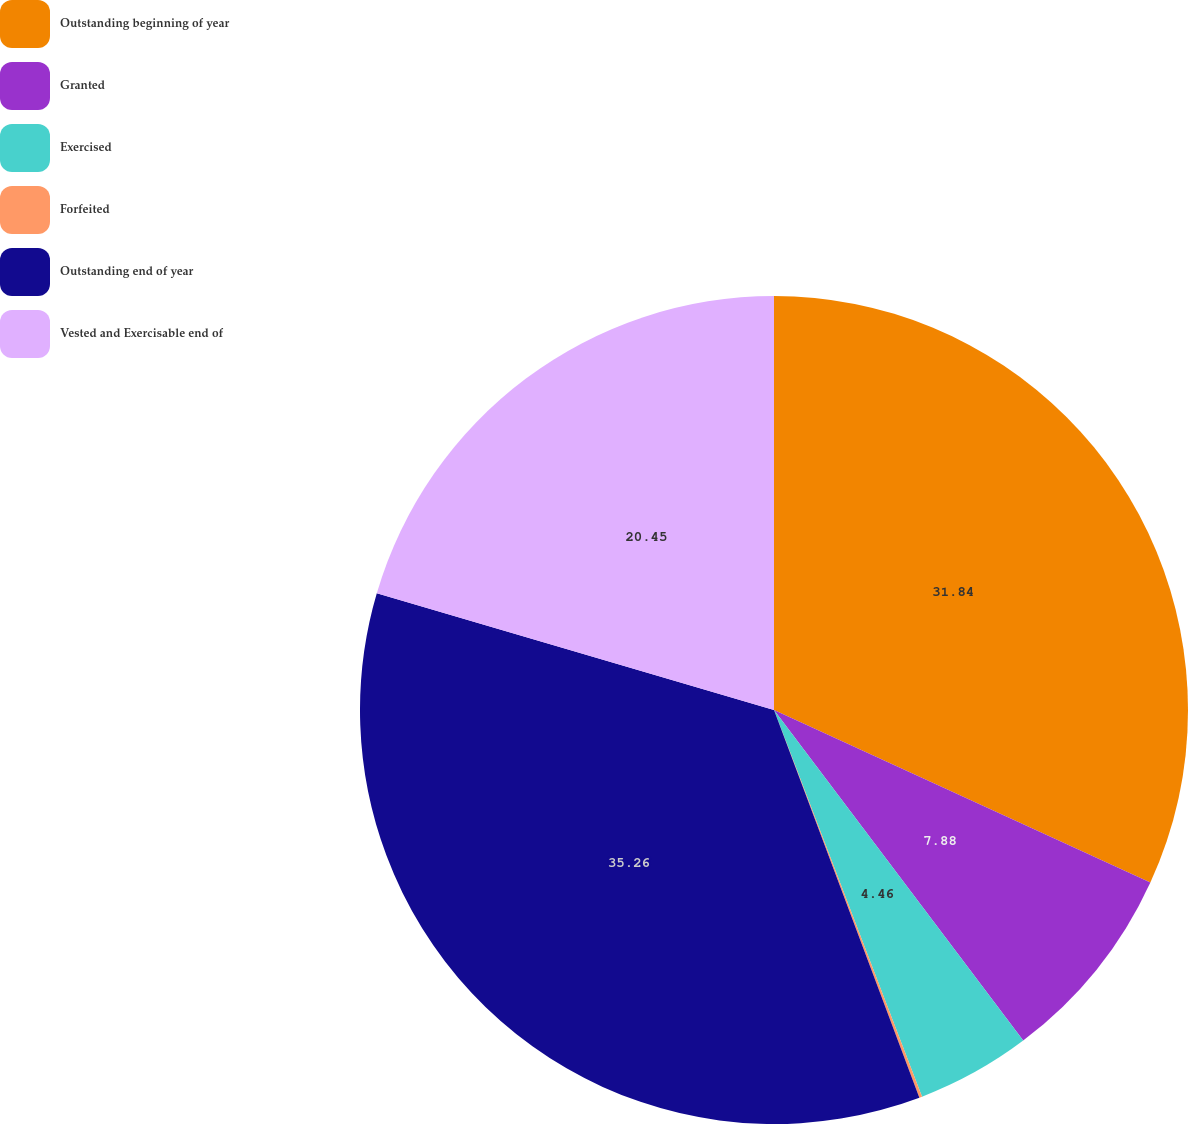Convert chart. <chart><loc_0><loc_0><loc_500><loc_500><pie_chart><fcel>Outstanding beginning of year<fcel>Granted<fcel>Exercised<fcel>Forfeited<fcel>Outstanding end of year<fcel>Vested and Exercisable end of<nl><fcel>31.84%<fcel>7.88%<fcel>4.46%<fcel>0.11%<fcel>35.26%<fcel>20.45%<nl></chart> 